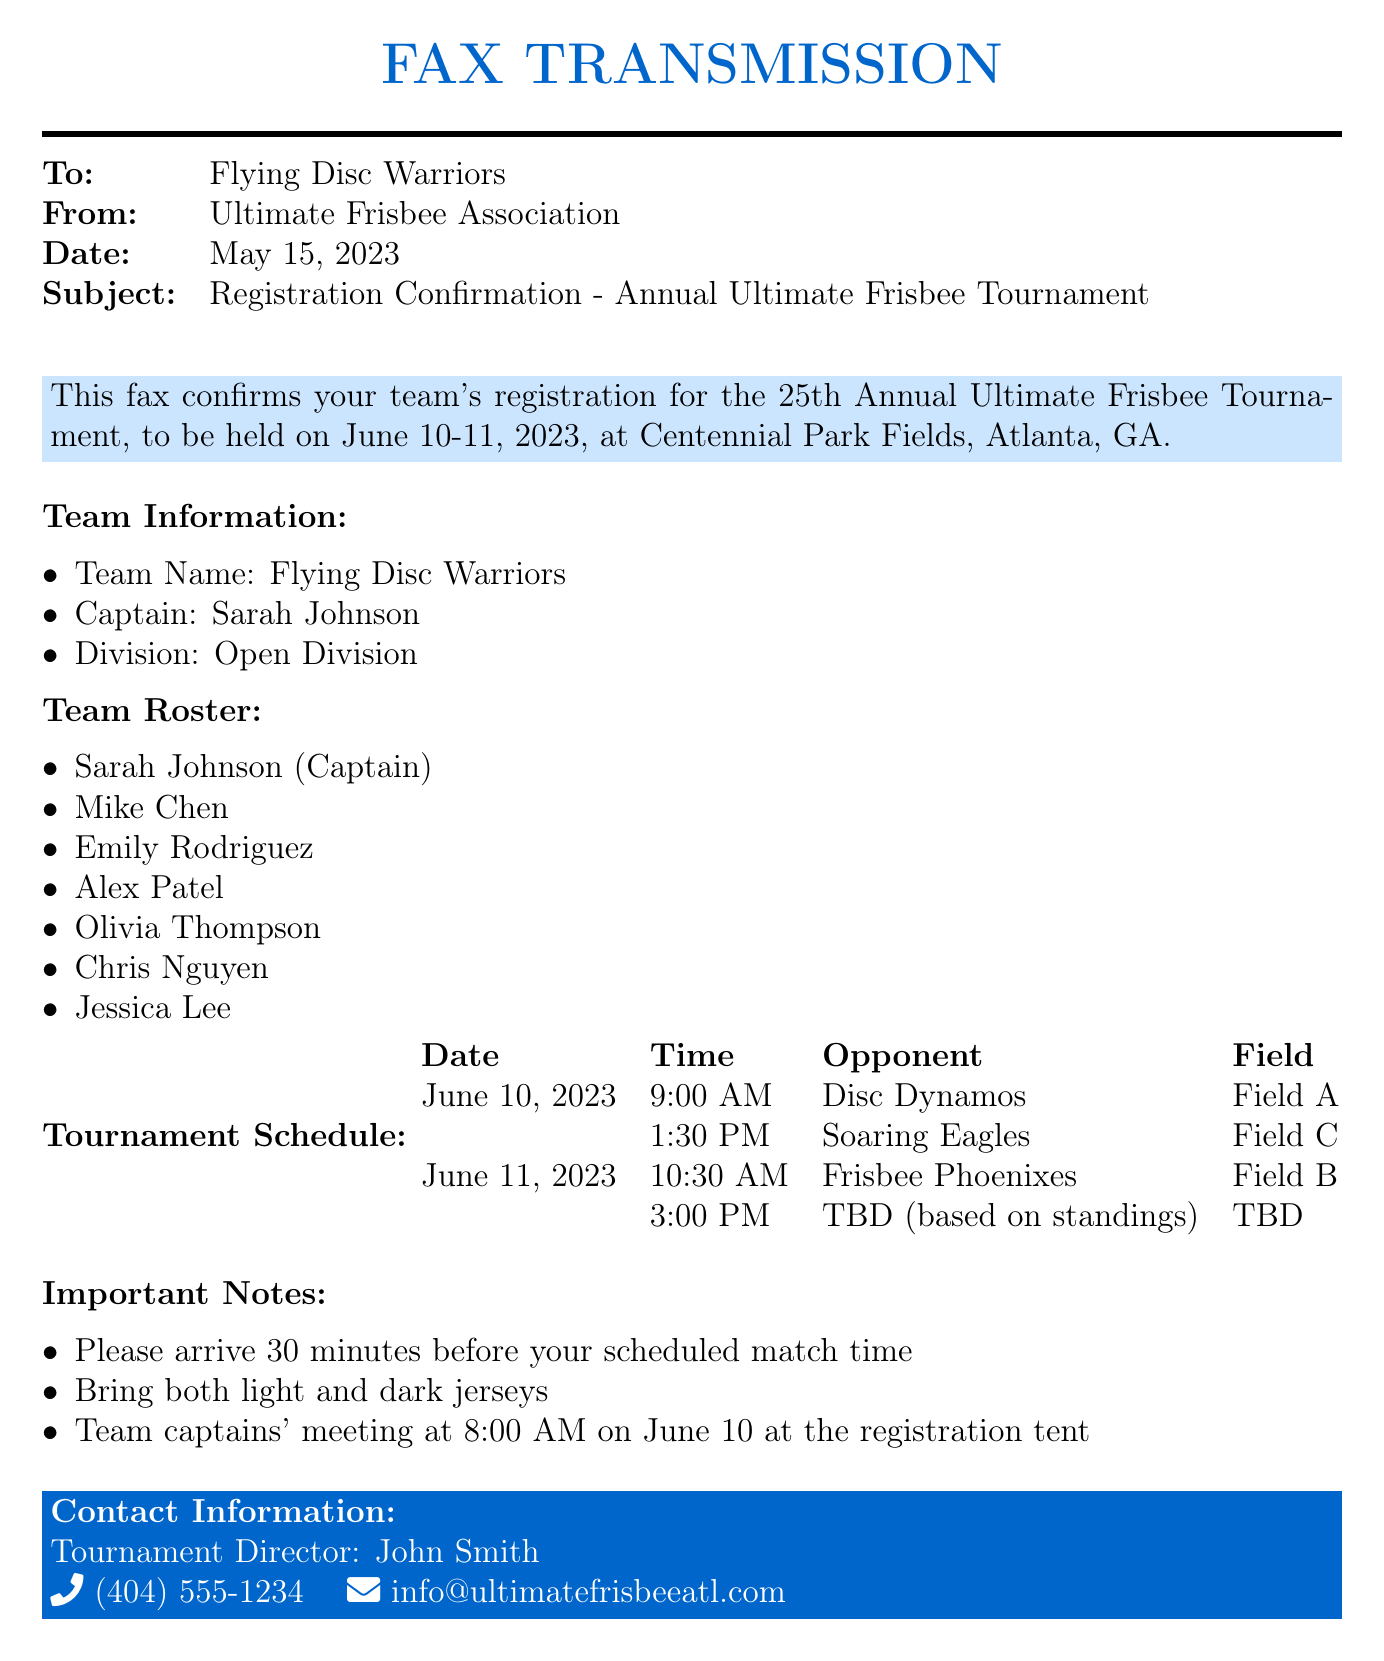what is the date of the tournament? The tournament is scheduled for June 10-11, 2023.
Answer: June 10-11, 2023 who is the captain of the team? The document lists Sarah Johnson as the captain of the Flying Disc Warriors.
Answer: Sarah Johnson what is the division of the Flying Disc Warriors? The Flying Disc Warriors are registered in the Open Division.
Answer: Open Division how many players are in the team roster? The team roster lists 7 players in total.
Answer: 7 what time is the first match on June 10? The first match is scheduled for 9:00 AM on June 10.
Answer: 9:00 AM which team will the Flying Disc Warriors face in their second match? The second match is against the Soaring Eagles.
Answer: Soaring Eagles what should teams bring to the tournament? Teams are advised to bring both light and dark jerseys.
Answer: both light and dark jerseys who should be contacted for more information? The contact person listed is the Tournament Director, John Smith.
Answer: John Smith when is the team captains' meeting? The meeting is set for 8:00 AM on June 10 at the registration tent.
Answer: 8:00 AM on June 10 